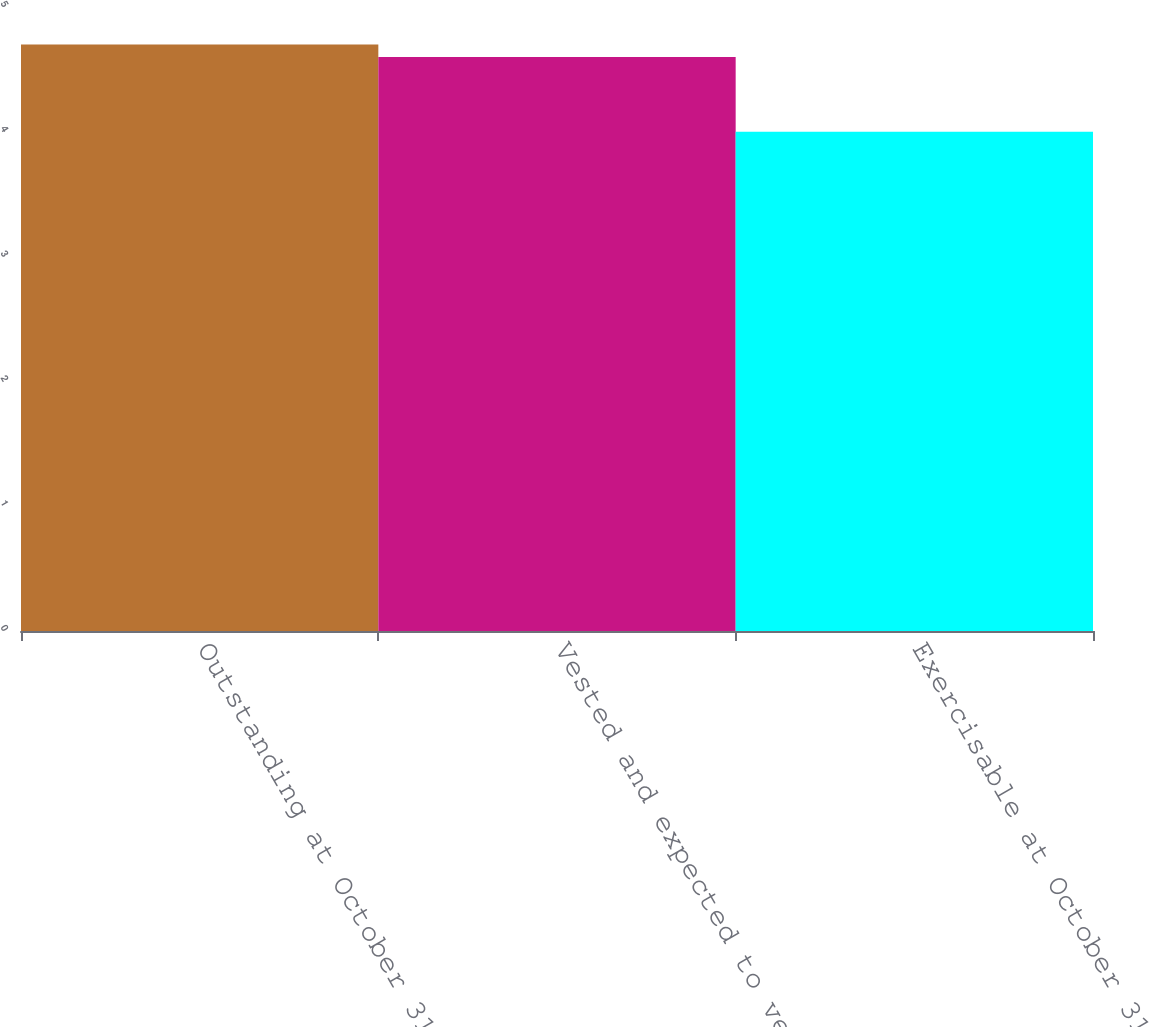Convert chart to OTSL. <chart><loc_0><loc_0><loc_500><loc_500><bar_chart><fcel>Outstanding at October 31 2006<fcel>Vested and expected to vest at<fcel>Exercisable at October 31 2006<nl><fcel>4.7<fcel>4.6<fcel>4<nl></chart> 